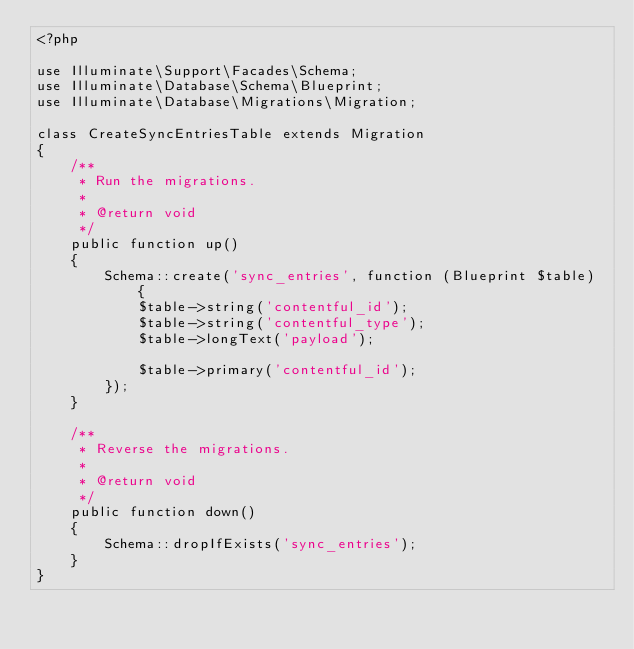<code> <loc_0><loc_0><loc_500><loc_500><_PHP_><?php

use Illuminate\Support\Facades\Schema;
use Illuminate\Database\Schema\Blueprint;
use Illuminate\Database\Migrations\Migration;

class CreateSyncEntriesTable extends Migration
{
    /**
     * Run the migrations.
     *
     * @return void
     */
    public function up()
    {
        Schema::create('sync_entries', function (Blueprint $table) {
            $table->string('contentful_id');
            $table->string('contentful_type');
            $table->longText('payload');

            $table->primary('contentful_id');
        });
    }

    /**
     * Reverse the migrations.
     *
     * @return void
     */
    public function down()
    {
        Schema::dropIfExists('sync_entries');
    }
}
</code> 